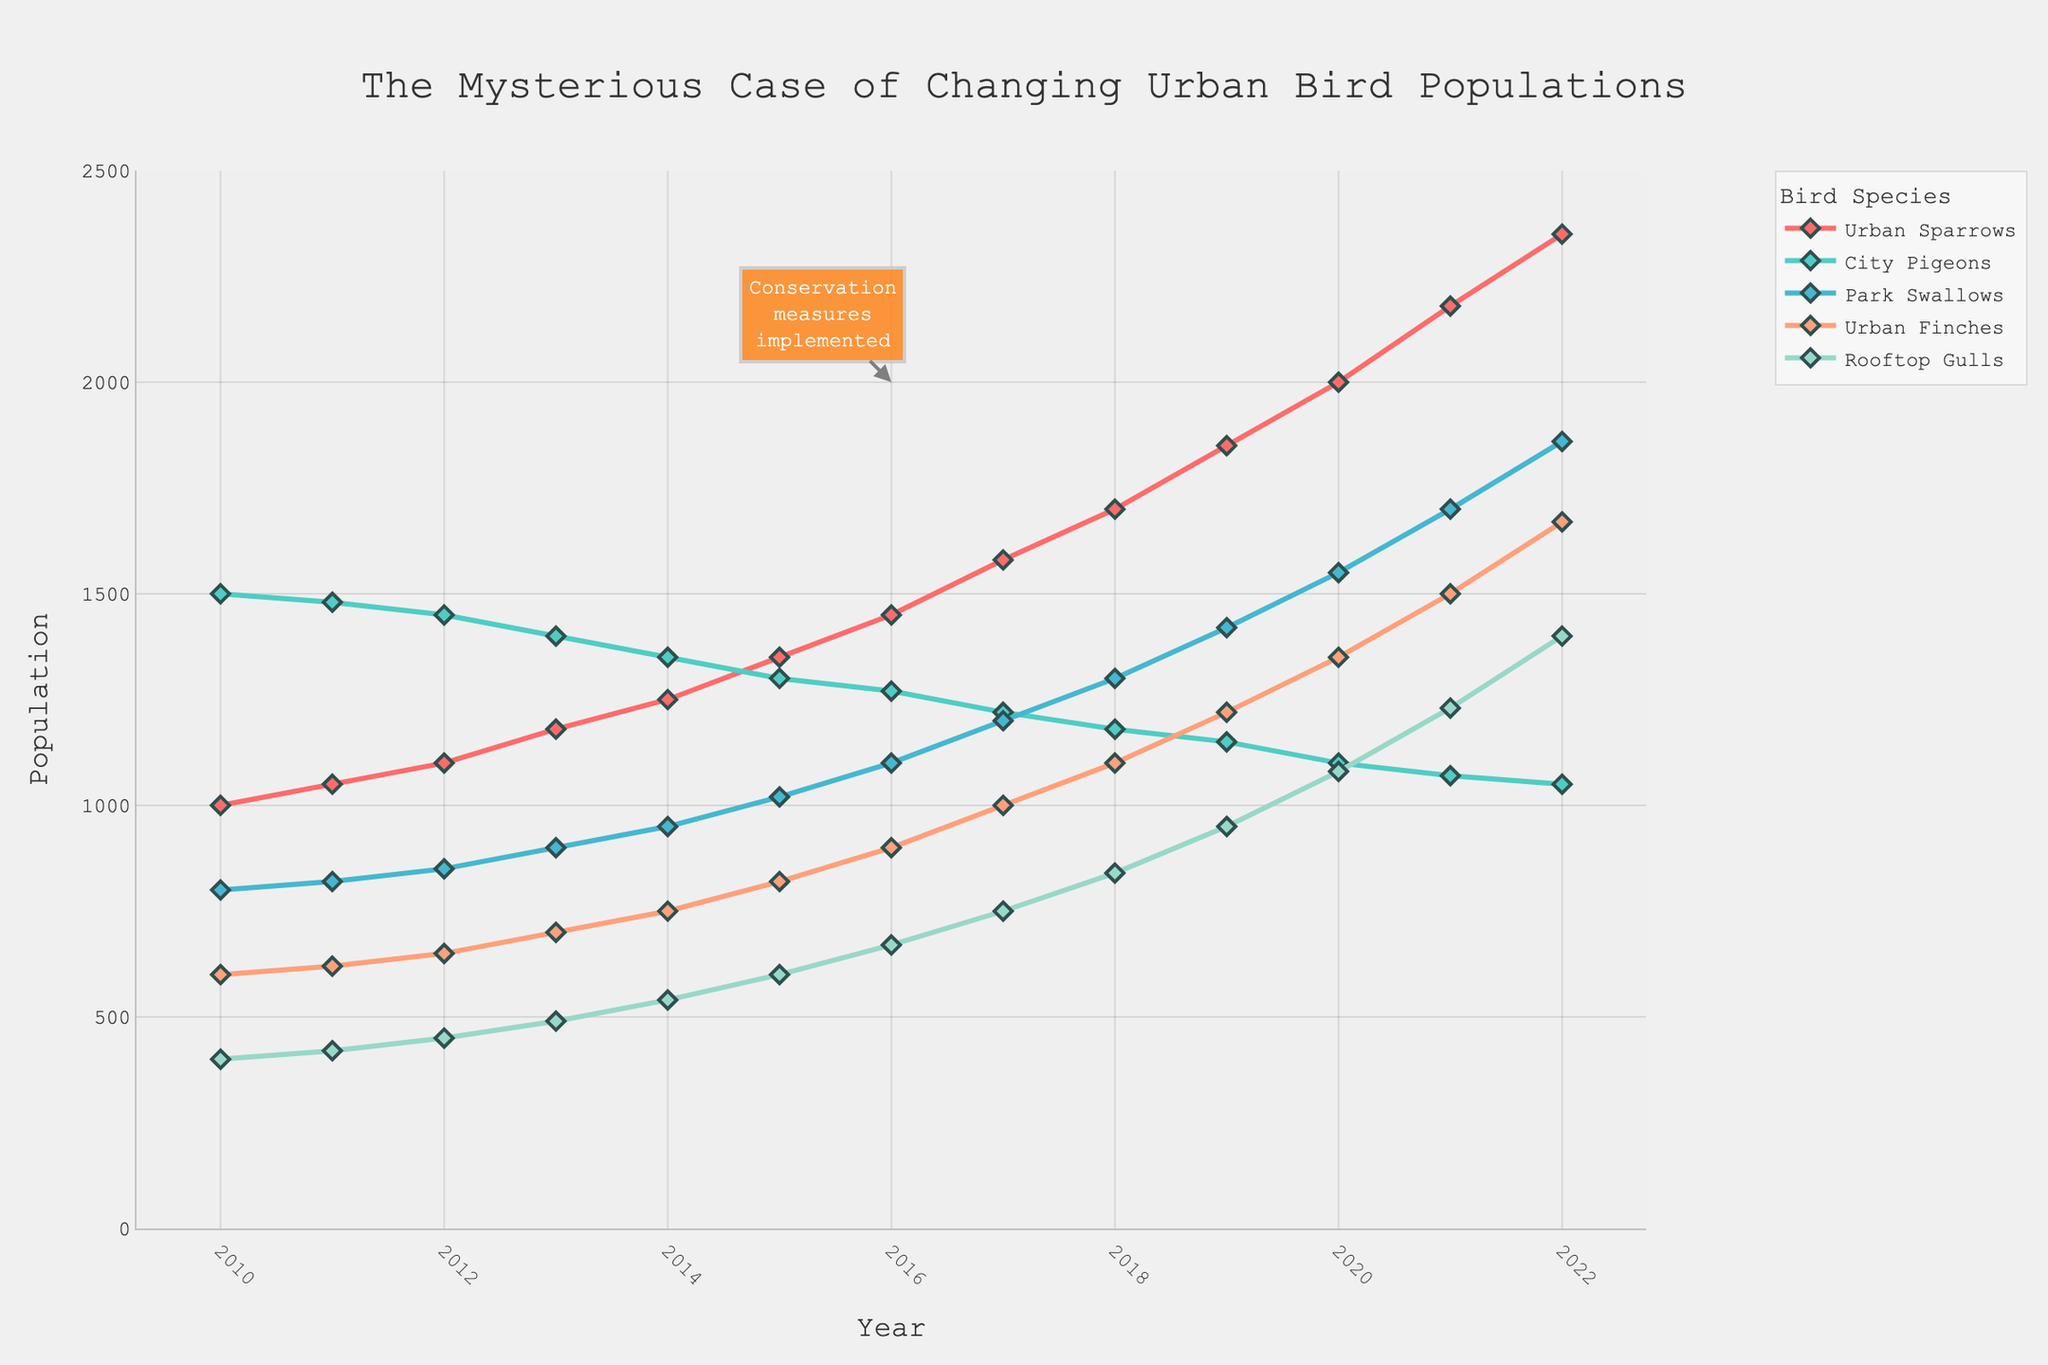What happened to the population of Urban Sparrows between 2010 and 2022? To determine the change in the population of Urban Sparrows between 2010 and 2022, compare the values at these two points in time. In 2010, the population was 1000. By 2022, it had increased to 2350. The difference is 2350 - 1000 = 1350.
Answer: The population increased by 1350 Which bird species had the highest population in 2022? Look at the data for 2022 and compare the populations of all bird species. Urban Sparrows had the highest population with 2350.
Answer: Urban Sparrows In which year did the population of Urban Finches exceed 1000? Find the year where the population of Urban Finches first exceeds 1000. According to the data, this happened in the year 2017 when the population reached 1000.
Answer: 2017 Which bird species showed the smallest population increase from 2010 to 2022? Calculate the difference in population from 2010 to 2022 for all species. The differences are: Urban Sparrows (1350), City Pigeons (-450), Park Swallows (1060), Urban Finches (1070), and Rooftop Gulls (1000). City Pigeons showed a decrease, while Rooftop Gulls had the smallest increase.
Answer: Rooftop Gulls Did any of the bird populations decline from 2010 to 2022? If so, which one(s)? Review the population change for each species between 2010 and 2022. City Pigeons declined from 1500 in 2010 to 1050 in 2022.
Answer: City Pigeons What can be inferred about the impact of conservation measures implemented in 2016 on the bird populations? Observe the trends before and after 2016. Most species show an increasing trend after 2016, especially Urban Sparrows and Park Swallows, suggesting that conservation measures likely had a positive impact.
Answer: Positive impact on most species By how much did the population of Rooftop Gulls change between 2016 and 2022? Calculate the population change for Rooftop Gulls between 2016 and 2022. The population increased from 670 to 1400, which is a change of 1400 - 670 = 730.
Answer: 730 Which year showed the maximum increase in the population of Park Swallows compared to the previous year? Compare the year-to-year population changes for Park Swallows and find the maximum increase. The largest yearly increase occurred between 2020 and 2021, with an increase from 1550 to 1700, which is a difference of 150.
Answer: Between 2020 and 2021 How did the population trends of Urban Sparrows and City Pigeons compare from 2010 to 2022? Look at the trends for both species over the years. Urban Sparrows consistently increased from 1000 to 2350, while City Pigeons consistently decreased from 1500 to 1050.
Answer: Urban Sparrows increased, City Pigeons decreased 